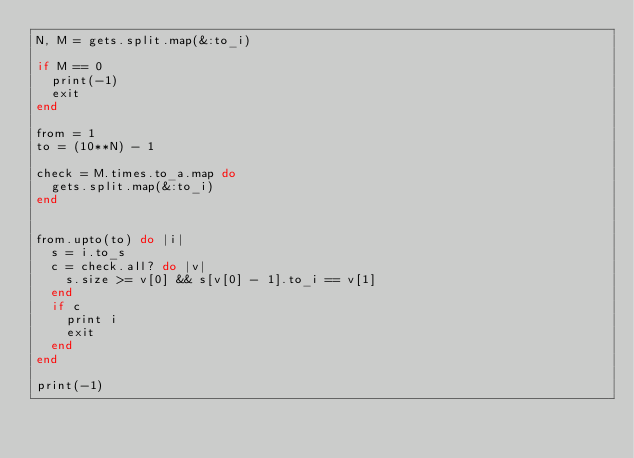<code> <loc_0><loc_0><loc_500><loc_500><_Ruby_>N, M = gets.split.map(&:to_i)

if M == 0
  print(-1)
  exit
end

from = 1
to = (10**N) - 1

check = M.times.to_a.map do
  gets.split.map(&:to_i)
end


from.upto(to) do |i|
  s = i.to_s
  c = check.all? do |v|
    s.size >= v[0] && s[v[0] - 1].to_i == v[1]
  end
  if c
    print i
    exit
  end
end

print(-1)
</code> 